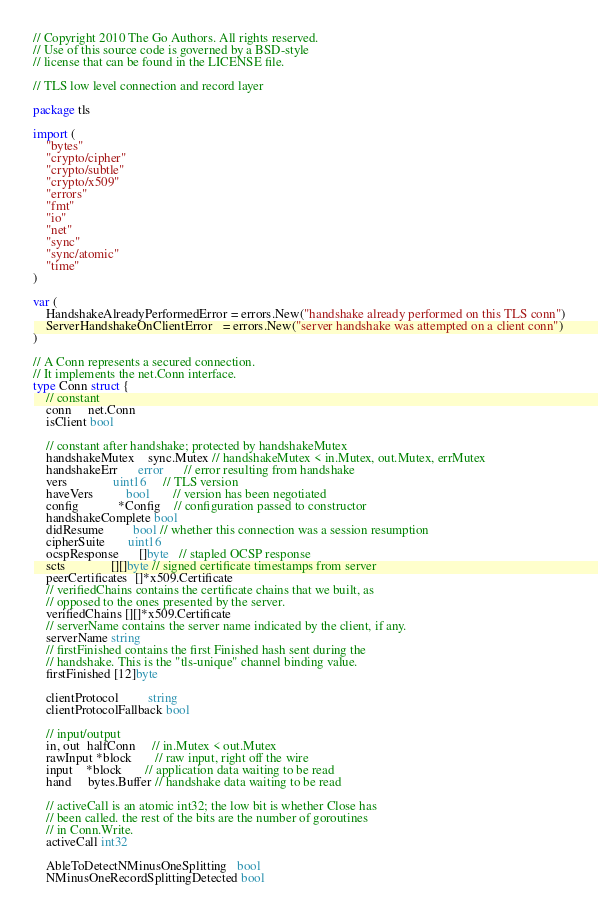Convert code to text. <code><loc_0><loc_0><loc_500><loc_500><_Go_>// Copyright 2010 The Go Authors. All rights reserved.
// Use of this source code is governed by a BSD-style
// license that can be found in the LICENSE file.

// TLS low level connection and record layer

package tls

import (
	"bytes"
	"crypto/cipher"
	"crypto/subtle"
	"crypto/x509"
	"errors"
	"fmt"
	"io"
	"net"
	"sync"
	"sync/atomic"
	"time"
)

var (
	HandshakeAlreadyPerformedError = errors.New("handshake already performed on this TLS conn")
	ServerHandshakeOnClientError   = errors.New("server handshake was attempted on a client conn")
)

// A Conn represents a secured connection.
// It implements the net.Conn interface.
type Conn struct {
	// constant
	conn     net.Conn
	isClient bool

	// constant after handshake; protected by handshakeMutex
	handshakeMutex    sync.Mutex // handshakeMutex < in.Mutex, out.Mutex, errMutex
	handshakeErr      error      // error resulting from handshake
	vers              uint16     // TLS version
	haveVers          bool       // version has been negotiated
	config            *Config    // configuration passed to constructor
	handshakeComplete bool
	didResume         bool // whether this connection was a session resumption
	cipherSuite       uint16
	ocspResponse      []byte   // stapled OCSP response
	scts              [][]byte // signed certificate timestamps from server
	peerCertificates  []*x509.Certificate
	// verifiedChains contains the certificate chains that we built, as
	// opposed to the ones presented by the server.
	verifiedChains [][]*x509.Certificate
	// serverName contains the server name indicated by the client, if any.
	serverName string
	// firstFinished contains the first Finished hash sent during the
	// handshake. This is the "tls-unique" channel binding value.
	firstFinished [12]byte

	clientProtocol         string
	clientProtocolFallback bool

	// input/output
	in, out  halfConn     // in.Mutex < out.Mutex
	rawInput *block       // raw input, right off the wire
	input    *block       // application data waiting to be read
	hand     bytes.Buffer // handshake data waiting to be read

	// activeCall is an atomic int32; the low bit is whether Close has
	// been called. the rest of the bits are the number of goroutines
	// in Conn.Write.
	activeCall int32

	AbleToDetectNMinusOneSplitting   bool
	NMinusOneRecordSplittingDetected bool</code> 